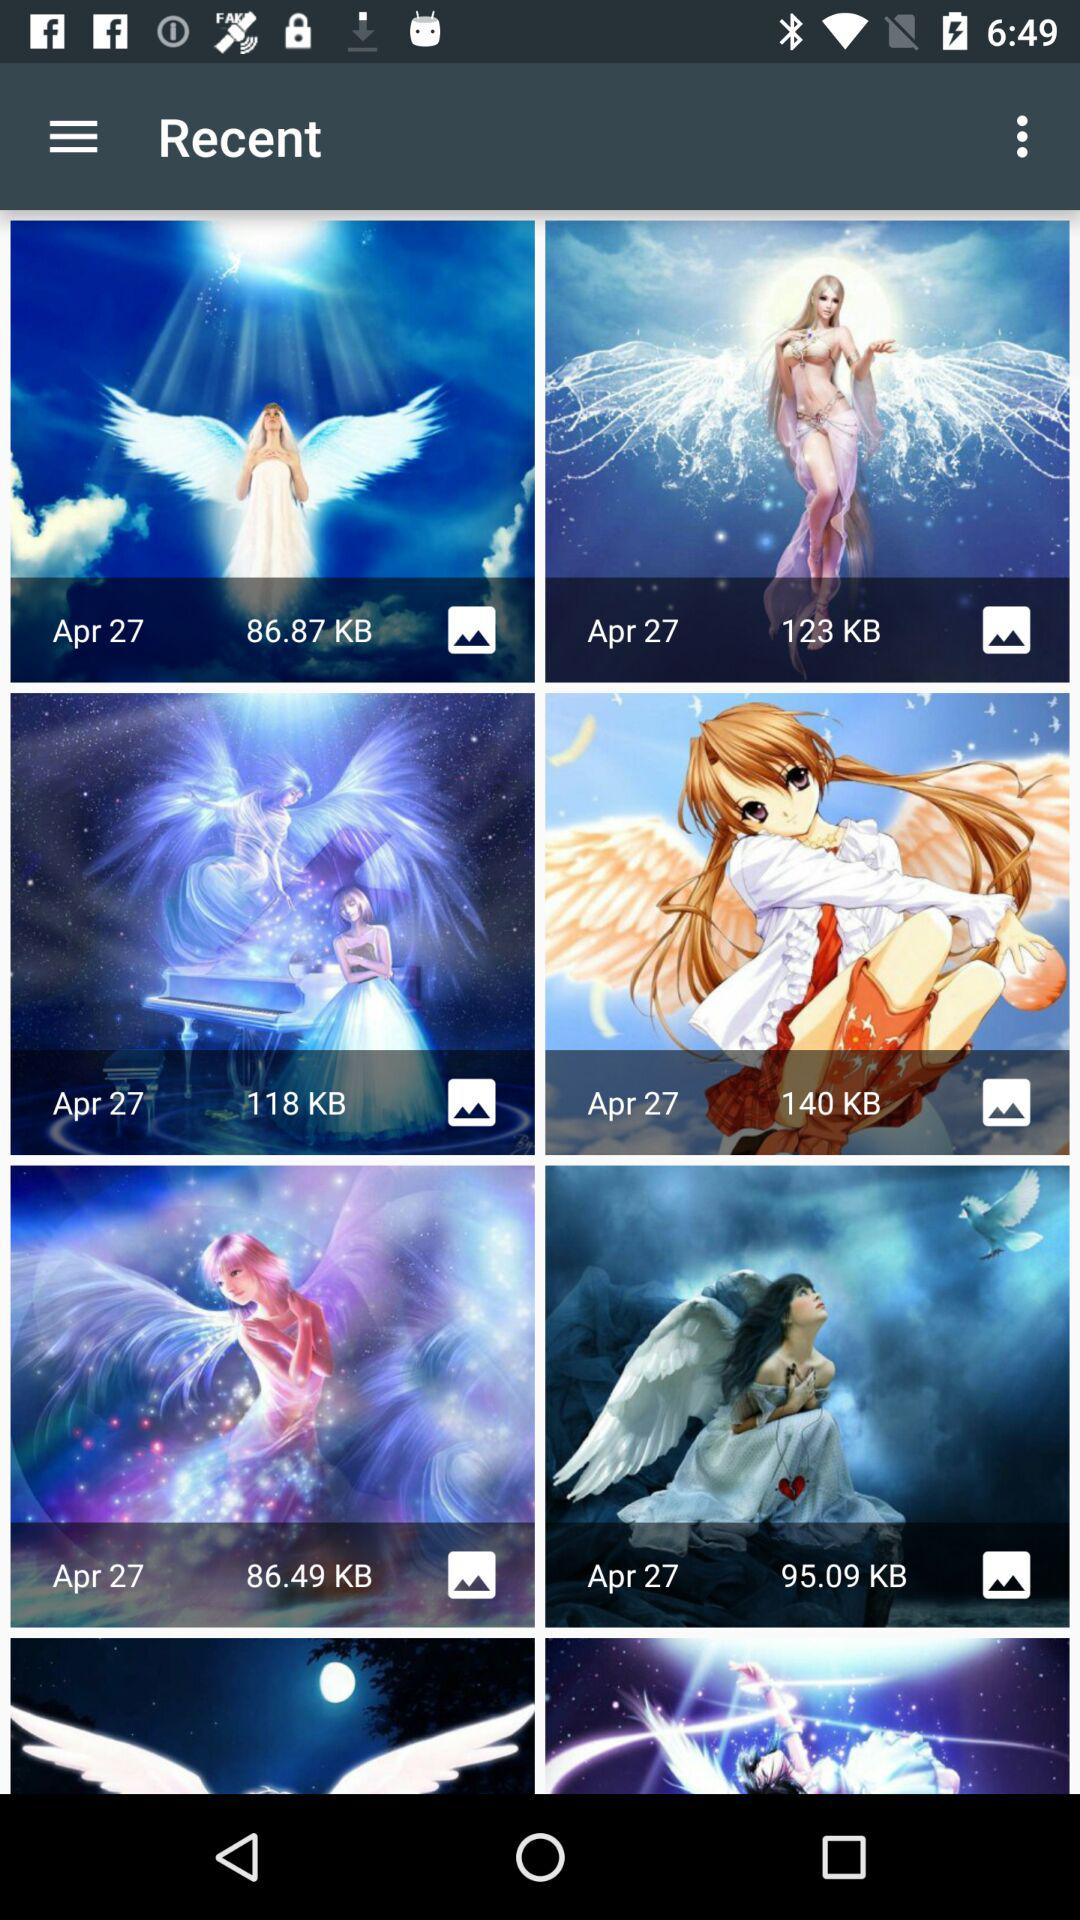What date is showing? The showing date is April 27. 